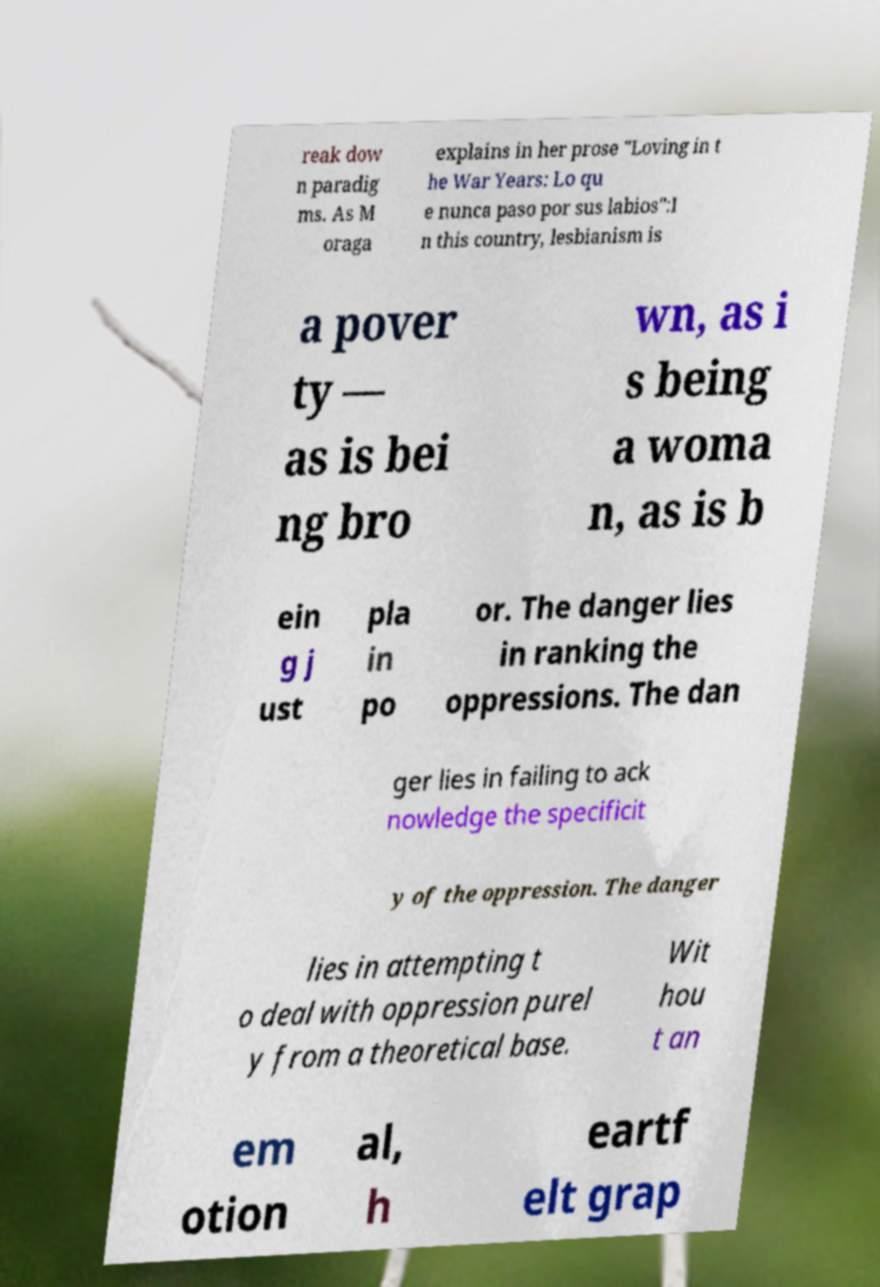Please read and relay the text visible in this image. What does it say? reak dow n paradig ms. As M oraga explains in her prose "Loving in t he War Years: Lo qu e nunca paso por sus labios":I n this country, lesbianism is a pover ty — as is bei ng bro wn, as i s being a woma n, as is b ein g j ust pla in po or. The danger lies in ranking the oppressions. The dan ger lies in failing to ack nowledge the specificit y of the oppression. The danger lies in attempting t o deal with oppression purel y from a theoretical base. Wit hou t an em otion al, h eartf elt grap 